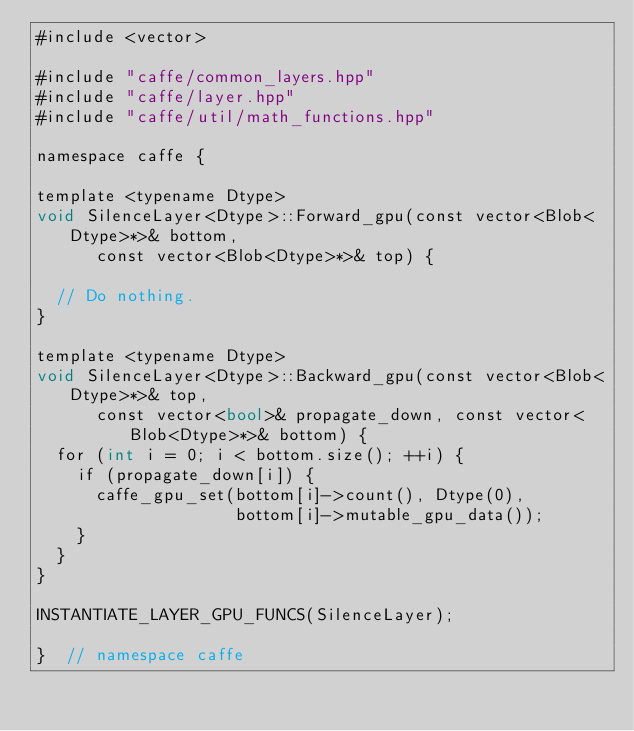<code> <loc_0><loc_0><loc_500><loc_500><_Cuda_>#include <vector>

#include "caffe/common_layers.hpp"
#include "caffe/layer.hpp"
#include "caffe/util/math_functions.hpp"

namespace caffe {

template <typename Dtype>
void SilenceLayer<Dtype>::Forward_gpu(const vector<Blob<Dtype>*>& bottom,
      const vector<Blob<Dtype>*>& top) {

  // Do nothing.
}

template <typename Dtype>
void SilenceLayer<Dtype>::Backward_gpu(const vector<Blob<Dtype>*>& top,
      const vector<bool>& propagate_down, const vector<Blob<Dtype>*>& bottom) {
  for (int i = 0; i < bottom.size(); ++i) {
    if (propagate_down[i]) {
      caffe_gpu_set(bottom[i]->count(), Dtype(0),
                    bottom[i]->mutable_gpu_data());
    }
  }
}

INSTANTIATE_LAYER_GPU_FUNCS(SilenceLayer);

}  // namespace caffe
</code> 